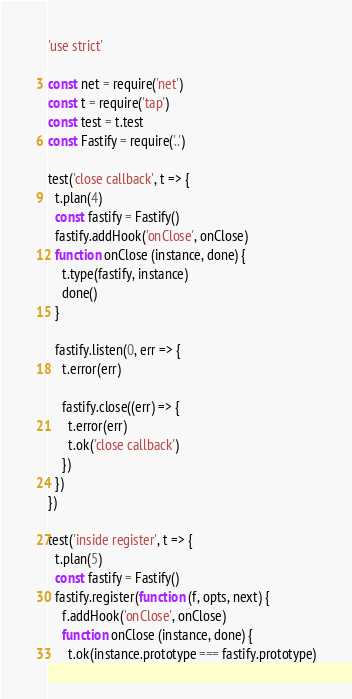Convert code to text. <code><loc_0><loc_0><loc_500><loc_500><_JavaScript_>'use strict'

const net = require('net')
const t = require('tap')
const test = t.test
const Fastify = require('..')

test('close callback', t => {
  t.plan(4)
  const fastify = Fastify()
  fastify.addHook('onClose', onClose)
  function onClose (instance, done) {
    t.type(fastify, instance)
    done()
  }

  fastify.listen(0, err => {
    t.error(err)

    fastify.close((err) => {
      t.error(err)
      t.ok('close callback')
    })
  })
})

test('inside register', t => {
  t.plan(5)
  const fastify = Fastify()
  fastify.register(function (f, opts, next) {
    f.addHook('onClose', onClose)
    function onClose (instance, done) {
      t.ok(instance.prototype === fastify.prototype)</code> 